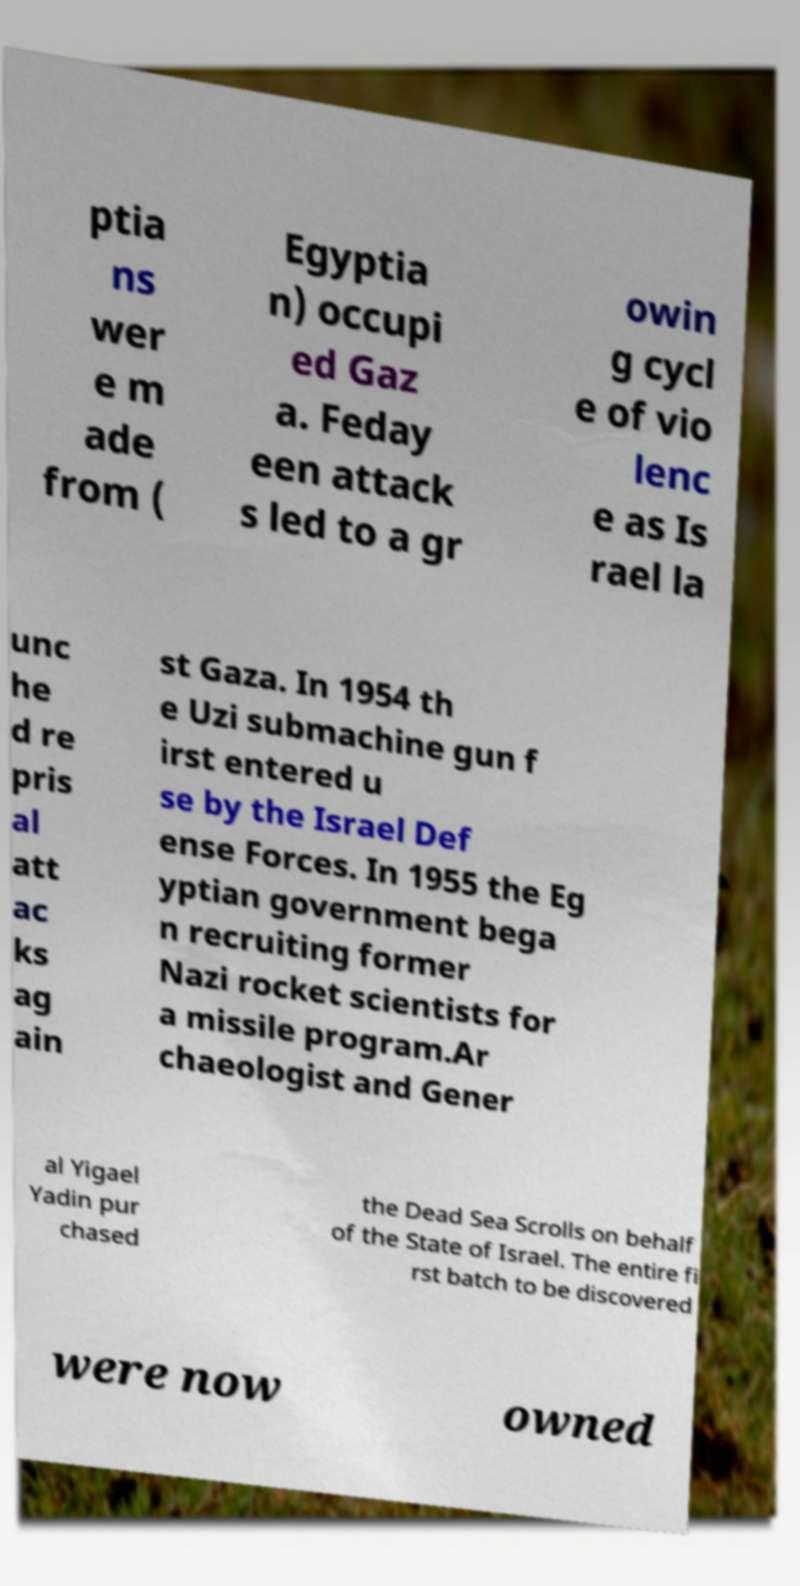I need the written content from this picture converted into text. Can you do that? ptia ns wer e m ade from ( Egyptia n) occupi ed Gaz a. Feday een attack s led to a gr owin g cycl e of vio lenc e as Is rael la unc he d re pris al att ac ks ag ain st Gaza. In 1954 th e Uzi submachine gun f irst entered u se by the Israel Def ense Forces. In 1955 the Eg yptian government bega n recruiting former Nazi rocket scientists for a missile program.Ar chaeologist and Gener al Yigael Yadin pur chased the Dead Sea Scrolls on behalf of the State of Israel. The entire fi rst batch to be discovered were now owned 